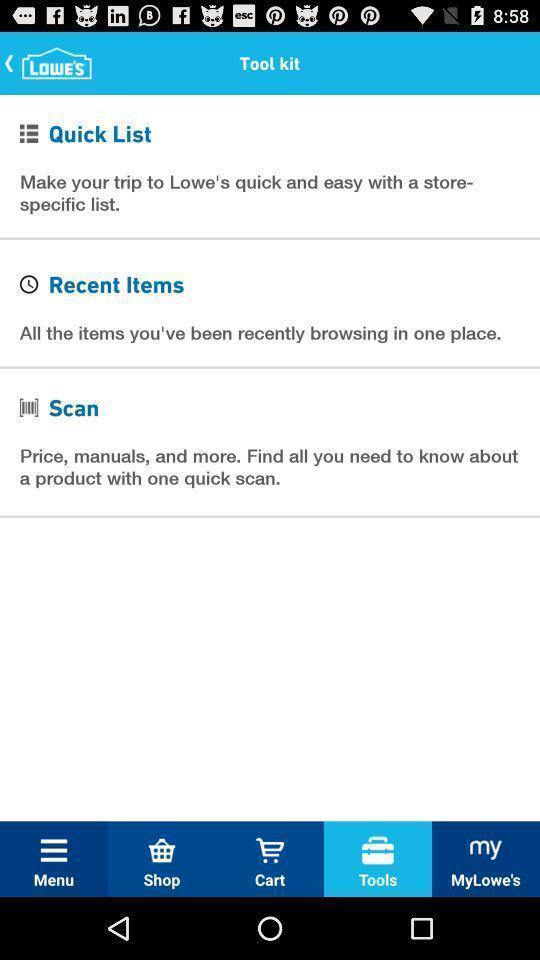What can you discern from this picture? Page displays tools in app. 